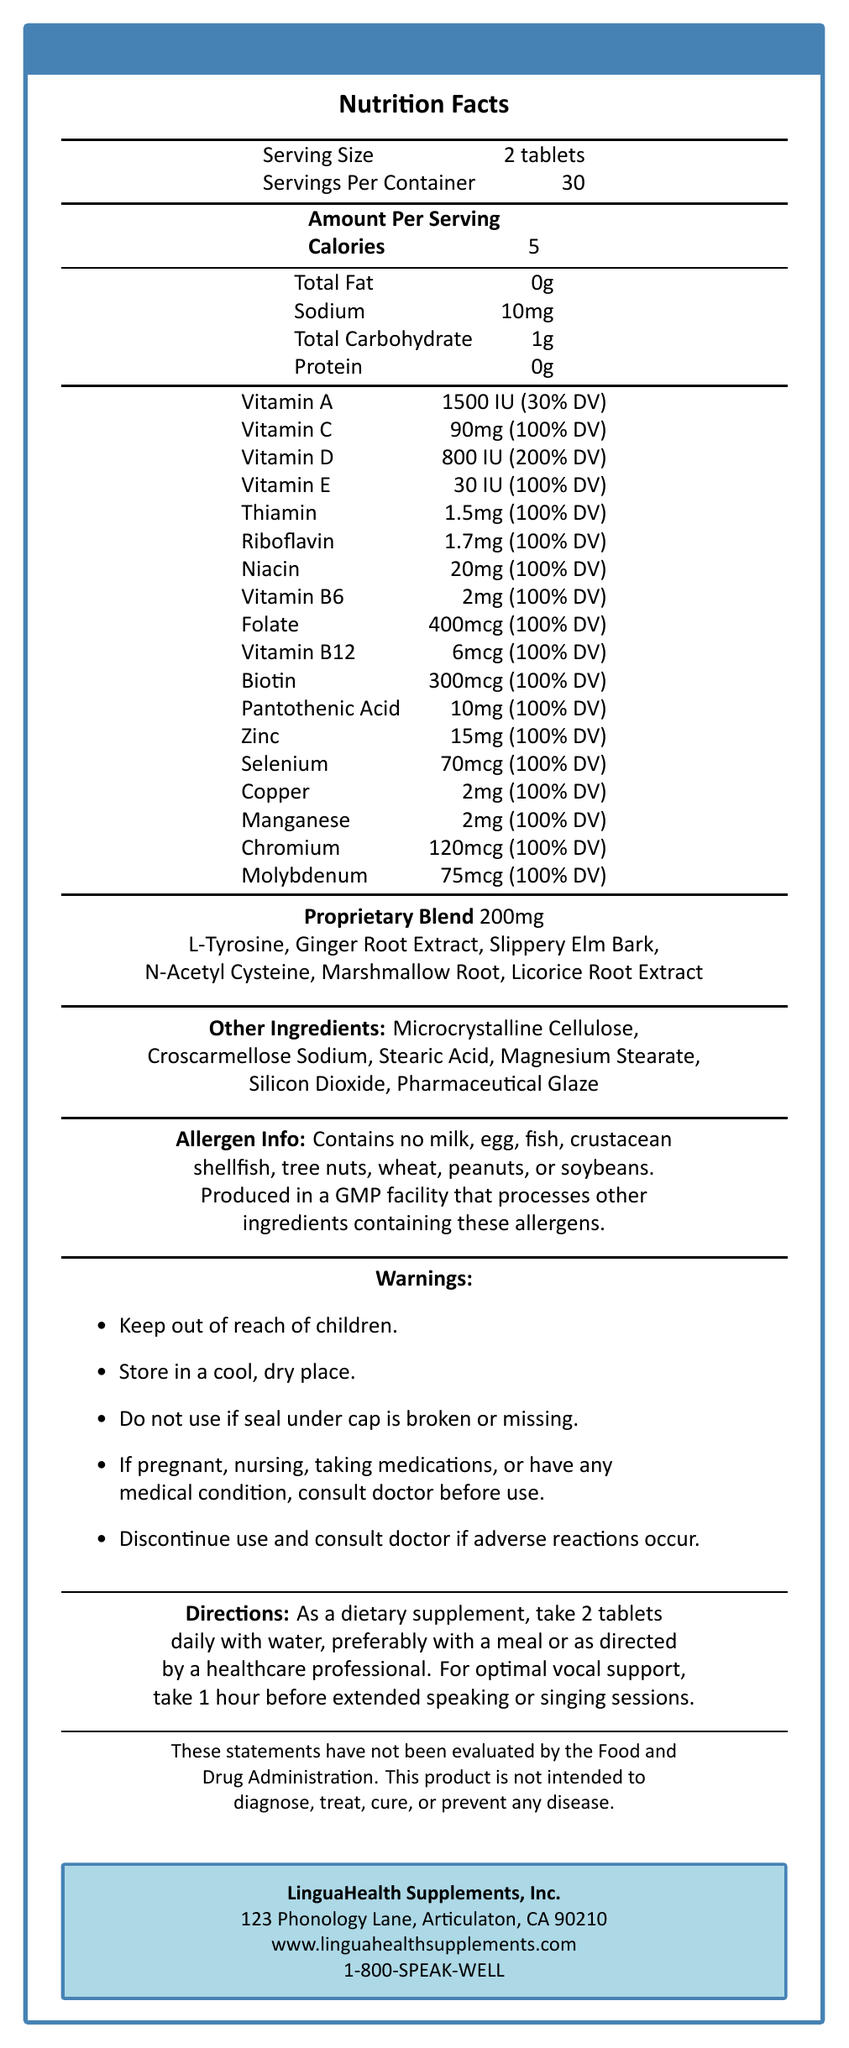which product is detailed in the nutrition facts label? The title of the document clearly states the product name as "VocalCare Pro: Linguist's Phonation Support."
Answer: VocalCare Pro: Linguist's Phonation Support what is the serving size for this supplement? The serving size is listed as "2 tablets" in the document.
Answer: 2 tablets how many servings are in one container? The document mentions there are 30 servings per container.
Answer: 30 how many calories are there per serving? The amount of calories per serving is listed as 5.
Answer: 5 which vitamins are present in this supplement, and what are their daily values? The document lists the vitamins, and their daily values are given in percentages next to each vitamin; for example, Vitamin A is 30% DV, Vitamin C is 100% DV, and so forth.
Answer: Vitamins A, C, D, E, Thiamin, Riboflavin, Niacin, B6, Folate, B12, Biotin, Pantothenic Acid what is the amount of Vitamin D in each serving of the supplement? The amount of Vitamin D per serving is given as 800 IU, which is 200% of the daily value.
Answer: 800 IU (200% DV) which of the following minerals are included in the supplement? A. Calcium B. Zinc C. Iron D. Selenium The document lists Zinc and Selenium but does not mention Calcium or Iron.
Answer: B. Zinc, D. Selenium does this supplement contain any sodium? The document lists "Sodium: 10mg" in the nutritional content.
Answer: Yes, 10mg are there any allergens present in the supplement? The allergen info in the document states that it contains no milk, egg, fish, crustacean shellfish, tree nuts, wheat, peanuts, or soybeans.
Answer: No is it safe for pregnant women to use this supplement without consulting a doctor? The warnings section advises pregnant women to consult a doctor before using the supplement.
Answer: No describe the recommended usage for optimal vocal support. The directions section outlines the recommended daily use and suggests taking it an hour before extended vocal use.
Answer: Take 2 tablets daily with water, preferably with a meal or as directed by a healthcare professional. For optimal vocal support, take 1 hour before extended speaking or singing sessions. what is the total weight of the proprietary blend in the supplement? The proprietary blend in the supplement has a total weight of 200mg.
Answer: 200mg what are some of the ingredients in the proprietary blend? The document lists these specific ingredients within the proprietary blend.
Answer: L-Tyrosine, Ginger Root Extract, Slippery Elm Bark, N-Acetyl Cysteine, Marshmallow Root, Licorice Root Extract who is the manufacturer of this supplement? The manufacturer is listed as LinguaHealth Supplements, Inc. in the document.
Answer: LinguaHealth Supplements, Inc. what is the address of the manufacturer? The document provides the address as "123 Phonology Lane, Articulaton, CA 90210."
Answer: 123 Phonology Lane, Articulaton, CA 90210 can the supplement be used to treat medical conditions according to the document? The disclaimer states that the product is not intended to diagnose, treat, cure, or prevent any disease.
Answer: No can the proprietary blend of this supplement be determined visually? The exact composition and quantities of each ingredient in the proprietary blend cannot be determined from the document alone, as it only provides the total weight and a list of the ingredients.
Answer: No 